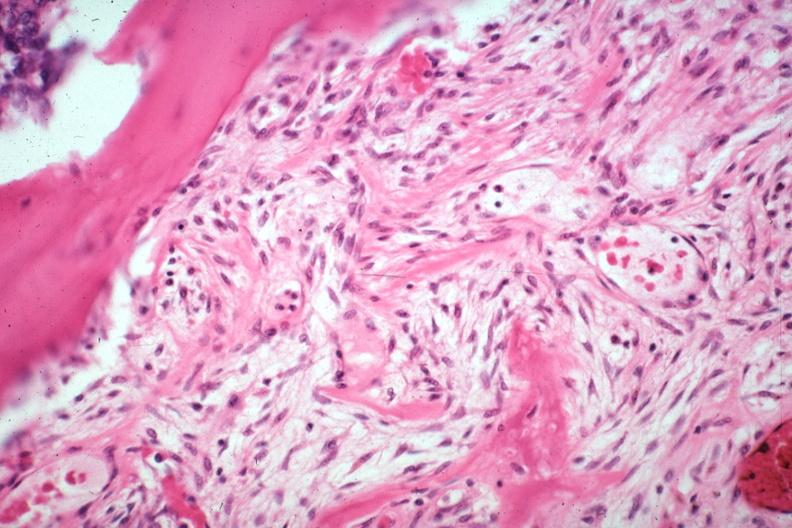what is tumor induced?
Answer the question using a single word or phrase. New bone formation large myofibroblastic osteoblastic cells in stroma with focus of osteoid case of 8 year survival breast intraductal papillary adenocarcinoma 